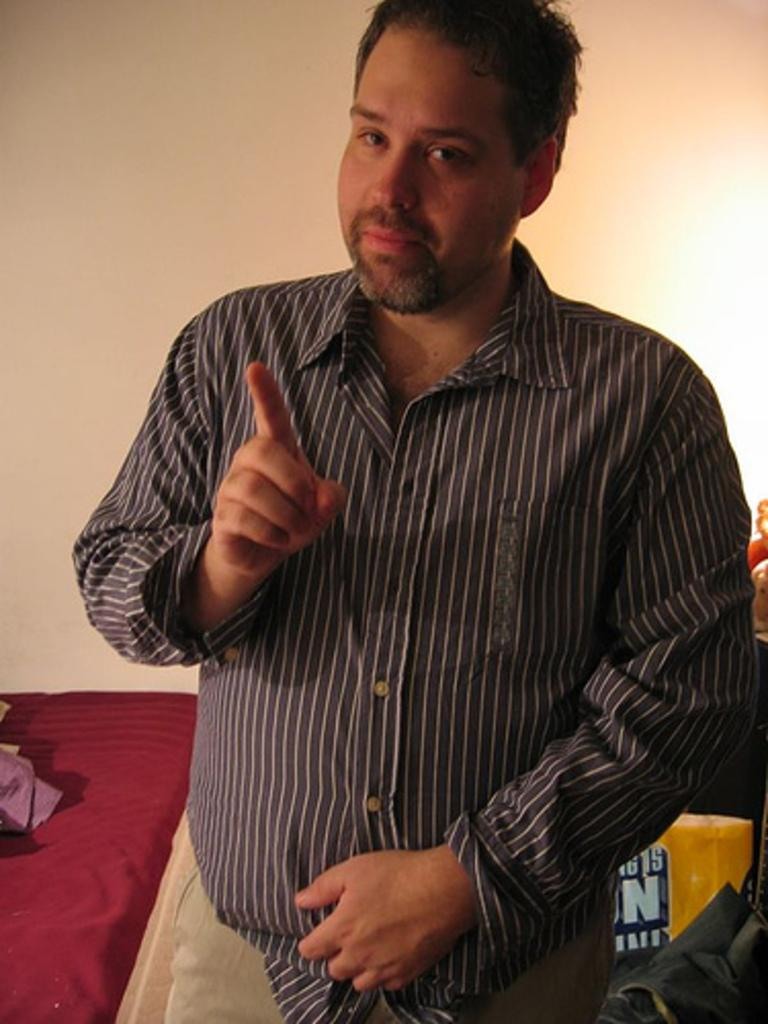What is the color of the wall in the image? There is a white color wall in the image. What type of furniture is present in the image? There is a bed in the image. Who or what is located in the front of the image? There is a man standing in the front of the image. What type of hospital equipment can be seen in the image? There is no hospital equipment present in the image. How does the man standing in the front of the image maintain his balance? The image does not provide information about how the man is maintaining his balance. What type of credit card is the man holding in the image? There is no credit card visible in the image. 